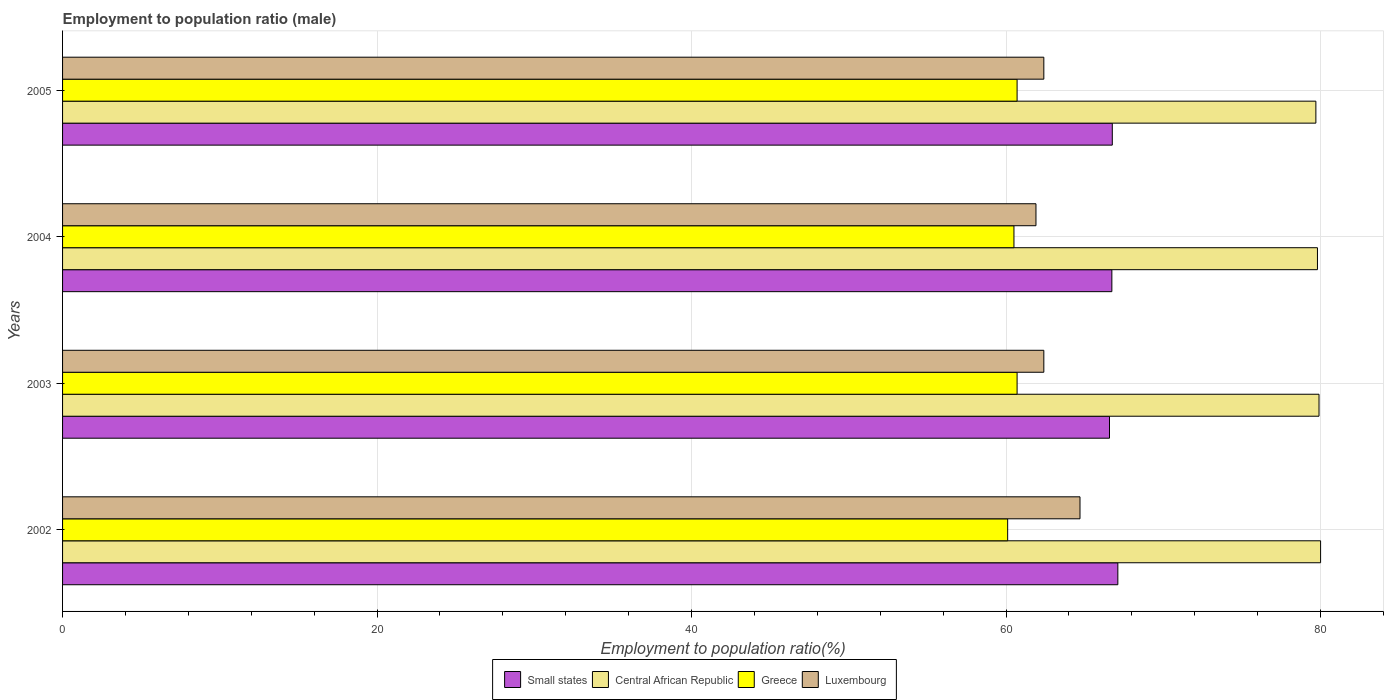How many different coloured bars are there?
Your response must be concise. 4. Are the number of bars on each tick of the Y-axis equal?
Offer a very short reply. Yes. What is the label of the 3rd group of bars from the top?
Make the answer very short. 2003. In how many cases, is the number of bars for a given year not equal to the number of legend labels?
Your answer should be compact. 0. What is the employment to population ratio in Greece in 2005?
Offer a very short reply. 60.7. Across all years, what is the maximum employment to population ratio in Luxembourg?
Give a very brief answer. 64.7. Across all years, what is the minimum employment to population ratio in Luxembourg?
Your answer should be compact. 61.9. In which year was the employment to population ratio in Small states maximum?
Ensure brevity in your answer.  2002. In which year was the employment to population ratio in Greece minimum?
Keep it short and to the point. 2002. What is the total employment to population ratio in Central African Republic in the graph?
Your answer should be compact. 319.4. What is the difference between the employment to population ratio in Small states in 2004 and that in 2005?
Your answer should be very brief. -0.03. What is the difference between the employment to population ratio in Central African Republic in 2004 and the employment to population ratio in Greece in 2002?
Keep it short and to the point. 19.7. What is the average employment to population ratio in Luxembourg per year?
Give a very brief answer. 62.85. In the year 2004, what is the difference between the employment to population ratio in Central African Republic and employment to population ratio in Small states?
Your answer should be very brief. 13.07. What is the ratio of the employment to population ratio in Greece in 2003 to that in 2004?
Keep it short and to the point. 1. What is the difference between the highest and the second highest employment to population ratio in Central African Republic?
Provide a short and direct response. 0.1. What is the difference between the highest and the lowest employment to population ratio in Central African Republic?
Provide a short and direct response. 0.3. Is the sum of the employment to population ratio in Small states in 2003 and 2005 greater than the maximum employment to population ratio in Central African Republic across all years?
Keep it short and to the point. Yes. Is it the case that in every year, the sum of the employment to population ratio in Greece and employment to population ratio in Small states is greater than the sum of employment to population ratio in Luxembourg and employment to population ratio in Central African Republic?
Offer a very short reply. No. What does the 1st bar from the top in 2002 represents?
Keep it short and to the point. Luxembourg. What does the 2nd bar from the bottom in 2002 represents?
Give a very brief answer. Central African Republic. Are all the bars in the graph horizontal?
Make the answer very short. Yes. Where does the legend appear in the graph?
Give a very brief answer. Bottom center. How many legend labels are there?
Provide a short and direct response. 4. What is the title of the graph?
Your answer should be very brief. Employment to population ratio (male). Does "Australia" appear as one of the legend labels in the graph?
Your answer should be compact. No. What is the label or title of the X-axis?
Make the answer very short. Employment to population ratio(%). What is the Employment to population ratio(%) of Small states in 2002?
Provide a succinct answer. 67.11. What is the Employment to population ratio(%) of Central African Republic in 2002?
Ensure brevity in your answer.  80. What is the Employment to population ratio(%) in Greece in 2002?
Keep it short and to the point. 60.1. What is the Employment to population ratio(%) in Luxembourg in 2002?
Ensure brevity in your answer.  64.7. What is the Employment to population ratio(%) of Small states in 2003?
Provide a short and direct response. 66.58. What is the Employment to population ratio(%) in Central African Republic in 2003?
Provide a succinct answer. 79.9. What is the Employment to population ratio(%) in Greece in 2003?
Offer a very short reply. 60.7. What is the Employment to population ratio(%) of Luxembourg in 2003?
Ensure brevity in your answer.  62.4. What is the Employment to population ratio(%) in Small states in 2004?
Your answer should be compact. 66.73. What is the Employment to population ratio(%) in Central African Republic in 2004?
Ensure brevity in your answer.  79.8. What is the Employment to population ratio(%) of Greece in 2004?
Your response must be concise. 60.5. What is the Employment to population ratio(%) of Luxembourg in 2004?
Offer a very short reply. 61.9. What is the Employment to population ratio(%) of Small states in 2005?
Offer a very short reply. 66.75. What is the Employment to population ratio(%) of Central African Republic in 2005?
Offer a very short reply. 79.7. What is the Employment to population ratio(%) of Greece in 2005?
Offer a very short reply. 60.7. What is the Employment to population ratio(%) in Luxembourg in 2005?
Make the answer very short. 62.4. Across all years, what is the maximum Employment to population ratio(%) in Small states?
Ensure brevity in your answer.  67.11. Across all years, what is the maximum Employment to population ratio(%) in Central African Republic?
Offer a terse response. 80. Across all years, what is the maximum Employment to population ratio(%) in Greece?
Keep it short and to the point. 60.7. Across all years, what is the maximum Employment to population ratio(%) in Luxembourg?
Keep it short and to the point. 64.7. Across all years, what is the minimum Employment to population ratio(%) of Small states?
Give a very brief answer. 66.58. Across all years, what is the minimum Employment to population ratio(%) of Central African Republic?
Give a very brief answer. 79.7. Across all years, what is the minimum Employment to population ratio(%) in Greece?
Your answer should be very brief. 60.1. Across all years, what is the minimum Employment to population ratio(%) in Luxembourg?
Provide a short and direct response. 61.9. What is the total Employment to population ratio(%) of Small states in the graph?
Give a very brief answer. 267.16. What is the total Employment to population ratio(%) of Central African Republic in the graph?
Your response must be concise. 319.4. What is the total Employment to population ratio(%) in Greece in the graph?
Your answer should be compact. 242. What is the total Employment to population ratio(%) of Luxembourg in the graph?
Your answer should be compact. 251.4. What is the difference between the Employment to population ratio(%) in Small states in 2002 and that in 2003?
Your response must be concise. 0.53. What is the difference between the Employment to population ratio(%) in Luxembourg in 2002 and that in 2003?
Offer a very short reply. 2.3. What is the difference between the Employment to population ratio(%) in Small states in 2002 and that in 2004?
Keep it short and to the point. 0.38. What is the difference between the Employment to population ratio(%) in Greece in 2002 and that in 2004?
Keep it short and to the point. -0.4. What is the difference between the Employment to population ratio(%) of Small states in 2002 and that in 2005?
Your answer should be compact. 0.35. What is the difference between the Employment to population ratio(%) in Central African Republic in 2002 and that in 2005?
Keep it short and to the point. 0.3. What is the difference between the Employment to population ratio(%) in Greece in 2002 and that in 2005?
Your answer should be very brief. -0.6. What is the difference between the Employment to population ratio(%) of Small states in 2003 and that in 2004?
Your answer should be compact. -0.15. What is the difference between the Employment to population ratio(%) in Central African Republic in 2003 and that in 2004?
Keep it short and to the point. 0.1. What is the difference between the Employment to population ratio(%) of Small states in 2003 and that in 2005?
Provide a succinct answer. -0.18. What is the difference between the Employment to population ratio(%) in Central African Republic in 2003 and that in 2005?
Your answer should be very brief. 0.2. What is the difference between the Employment to population ratio(%) in Luxembourg in 2003 and that in 2005?
Make the answer very short. 0. What is the difference between the Employment to population ratio(%) of Small states in 2004 and that in 2005?
Offer a terse response. -0.03. What is the difference between the Employment to population ratio(%) in Small states in 2002 and the Employment to population ratio(%) in Central African Republic in 2003?
Make the answer very short. -12.79. What is the difference between the Employment to population ratio(%) in Small states in 2002 and the Employment to population ratio(%) in Greece in 2003?
Your answer should be compact. 6.41. What is the difference between the Employment to population ratio(%) of Small states in 2002 and the Employment to population ratio(%) of Luxembourg in 2003?
Your response must be concise. 4.71. What is the difference between the Employment to population ratio(%) in Central African Republic in 2002 and the Employment to population ratio(%) in Greece in 2003?
Offer a terse response. 19.3. What is the difference between the Employment to population ratio(%) of Central African Republic in 2002 and the Employment to population ratio(%) of Luxembourg in 2003?
Your response must be concise. 17.6. What is the difference between the Employment to population ratio(%) in Small states in 2002 and the Employment to population ratio(%) in Central African Republic in 2004?
Make the answer very short. -12.69. What is the difference between the Employment to population ratio(%) of Small states in 2002 and the Employment to population ratio(%) of Greece in 2004?
Offer a terse response. 6.61. What is the difference between the Employment to population ratio(%) in Small states in 2002 and the Employment to population ratio(%) in Luxembourg in 2004?
Make the answer very short. 5.21. What is the difference between the Employment to population ratio(%) of Central African Republic in 2002 and the Employment to population ratio(%) of Greece in 2004?
Make the answer very short. 19.5. What is the difference between the Employment to population ratio(%) of Small states in 2002 and the Employment to population ratio(%) of Central African Republic in 2005?
Offer a terse response. -12.59. What is the difference between the Employment to population ratio(%) in Small states in 2002 and the Employment to population ratio(%) in Greece in 2005?
Provide a short and direct response. 6.41. What is the difference between the Employment to population ratio(%) in Small states in 2002 and the Employment to population ratio(%) in Luxembourg in 2005?
Make the answer very short. 4.71. What is the difference between the Employment to population ratio(%) in Central African Republic in 2002 and the Employment to population ratio(%) in Greece in 2005?
Make the answer very short. 19.3. What is the difference between the Employment to population ratio(%) in Small states in 2003 and the Employment to population ratio(%) in Central African Republic in 2004?
Make the answer very short. -13.22. What is the difference between the Employment to population ratio(%) in Small states in 2003 and the Employment to population ratio(%) in Greece in 2004?
Ensure brevity in your answer.  6.08. What is the difference between the Employment to population ratio(%) of Small states in 2003 and the Employment to population ratio(%) of Luxembourg in 2004?
Keep it short and to the point. 4.68. What is the difference between the Employment to population ratio(%) of Central African Republic in 2003 and the Employment to population ratio(%) of Greece in 2004?
Keep it short and to the point. 19.4. What is the difference between the Employment to population ratio(%) of Small states in 2003 and the Employment to population ratio(%) of Central African Republic in 2005?
Give a very brief answer. -13.12. What is the difference between the Employment to population ratio(%) of Small states in 2003 and the Employment to population ratio(%) of Greece in 2005?
Make the answer very short. 5.88. What is the difference between the Employment to population ratio(%) in Small states in 2003 and the Employment to population ratio(%) in Luxembourg in 2005?
Provide a short and direct response. 4.18. What is the difference between the Employment to population ratio(%) of Central African Republic in 2003 and the Employment to population ratio(%) of Greece in 2005?
Keep it short and to the point. 19.2. What is the difference between the Employment to population ratio(%) of Greece in 2003 and the Employment to population ratio(%) of Luxembourg in 2005?
Give a very brief answer. -1.7. What is the difference between the Employment to population ratio(%) in Small states in 2004 and the Employment to population ratio(%) in Central African Republic in 2005?
Keep it short and to the point. -12.97. What is the difference between the Employment to population ratio(%) of Small states in 2004 and the Employment to population ratio(%) of Greece in 2005?
Provide a short and direct response. 6.03. What is the difference between the Employment to population ratio(%) of Small states in 2004 and the Employment to population ratio(%) of Luxembourg in 2005?
Offer a terse response. 4.33. What is the difference between the Employment to population ratio(%) of Central African Republic in 2004 and the Employment to population ratio(%) of Greece in 2005?
Your response must be concise. 19.1. What is the difference between the Employment to population ratio(%) of Central African Republic in 2004 and the Employment to population ratio(%) of Luxembourg in 2005?
Offer a terse response. 17.4. What is the difference between the Employment to population ratio(%) of Greece in 2004 and the Employment to population ratio(%) of Luxembourg in 2005?
Your answer should be very brief. -1.9. What is the average Employment to population ratio(%) in Small states per year?
Provide a short and direct response. 66.79. What is the average Employment to population ratio(%) of Central African Republic per year?
Make the answer very short. 79.85. What is the average Employment to population ratio(%) in Greece per year?
Provide a succinct answer. 60.5. What is the average Employment to population ratio(%) of Luxembourg per year?
Offer a terse response. 62.85. In the year 2002, what is the difference between the Employment to population ratio(%) of Small states and Employment to population ratio(%) of Central African Republic?
Give a very brief answer. -12.89. In the year 2002, what is the difference between the Employment to population ratio(%) in Small states and Employment to population ratio(%) in Greece?
Keep it short and to the point. 7.01. In the year 2002, what is the difference between the Employment to population ratio(%) in Small states and Employment to population ratio(%) in Luxembourg?
Give a very brief answer. 2.41. In the year 2002, what is the difference between the Employment to population ratio(%) of Central African Republic and Employment to population ratio(%) of Greece?
Your answer should be very brief. 19.9. In the year 2002, what is the difference between the Employment to population ratio(%) in Central African Republic and Employment to population ratio(%) in Luxembourg?
Your answer should be very brief. 15.3. In the year 2002, what is the difference between the Employment to population ratio(%) of Greece and Employment to population ratio(%) of Luxembourg?
Your answer should be very brief. -4.6. In the year 2003, what is the difference between the Employment to population ratio(%) of Small states and Employment to population ratio(%) of Central African Republic?
Offer a terse response. -13.32. In the year 2003, what is the difference between the Employment to population ratio(%) of Small states and Employment to population ratio(%) of Greece?
Offer a very short reply. 5.88. In the year 2003, what is the difference between the Employment to population ratio(%) of Small states and Employment to population ratio(%) of Luxembourg?
Your response must be concise. 4.18. In the year 2003, what is the difference between the Employment to population ratio(%) in Central African Republic and Employment to population ratio(%) in Greece?
Offer a terse response. 19.2. In the year 2003, what is the difference between the Employment to population ratio(%) in Central African Republic and Employment to population ratio(%) in Luxembourg?
Give a very brief answer. 17.5. In the year 2004, what is the difference between the Employment to population ratio(%) in Small states and Employment to population ratio(%) in Central African Republic?
Ensure brevity in your answer.  -13.07. In the year 2004, what is the difference between the Employment to population ratio(%) in Small states and Employment to population ratio(%) in Greece?
Your answer should be compact. 6.23. In the year 2004, what is the difference between the Employment to population ratio(%) of Small states and Employment to population ratio(%) of Luxembourg?
Your response must be concise. 4.83. In the year 2004, what is the difference between the Employment to population ratio(%) of Central African Republic and Employment to population ratio(%) of Greece?
Give a very brief answer. 19.3. In the year 2004, what is the difference between the Employment to population ratio(%) of Central African Republic and Employment to population ratio(%) of Luxembourg?
Your answer should be compact. 17.9. In the year 2004, what is the difference between the Employment to population ratio(%) of Greece and Employment to population ratio(%) of Luxembourg?
Your answer should be very brief. -1.4. In the year 2005, what is the difference between the Employment to population ratio(%) in Small states and Employment to population ratio(%) in Central African Republic?
Offer a very short reply. -12.95. In the year 2005, what is the difference between the Employment to population ratio(%) of Small states and Employment to population ratio(%) of Greece?
Your response must be concise. 6.05. In the year 2005, what is the difference between the Employment to population ratio(%) of Small states and Employment to population ratio(%) of Luxembourg?
Ensure brevity in your answer.  4.35. In the year 2005, what is the difference between the Employment to population ratio(%) of Central African Republic and Employment to population ratio(%) of Greece?
Make the answer very short. 19. In the year 2005, what is the difference between the Employment to population ratio(%) of Greece and Employment to population ratio(%) of Luxembourg?
Give a very brief answer. -1.7. What is the ratio of the Employment to population ratio(%) in Luxembourg in 2002 to that in 2003?
Provide a short and direct response. 1.04. What is the ratio of the Employment to population ratio(%) in Small states in 2002 to that in 2004?
Your answer should be compact. 1.01. What is the ratio of the Employment to population ratio(%) of Central African Republic in 2002 to that in 2004?
Ensure brevity in your answer.  1. What is the ratio of the Employment to population ratio(%) of Greece in 2002 to that in 2004?
Make the answer very short. 0.99. What is the ratio of the Employment to population ratio(%) of Luxembourg in 2002 to that in 2004?
Provide a short and direct response. 1.05. What is the ratio of the Employment to population ratio(%) in Central African Republic in 2002 to that in 2005?
Your answer should be very brief. 1. What is the ratio of the Employment to population ratio(%) of Greece in 2002 to that in 2005?
Keep it short and to the point. 0.99. What is the ratio of the Employment to population ratio(%) of Luxembourg in 2002 to that in 2005?
Your answer should be compact. 1.04. What is the ratio of the Employment to population ratio(%) of Small states in 2003 to that in 2004?
Provide a short and direct response. 1. What is the ratio of the Employment to population ratio(%) in Central African Republic in 2003 to that in 2004?
Give a very brief answer. 1. What is the ratio of the Employment to population ratio(%) in Greece in 2003 to that in 2004?
Keep it short and to the point. 1. What is the ratio of the Employment to population ratio(%) in Luxembourg in 2003 to that in 2004?
Provide a short and direct response. 1.01. What is the ratio of the Employment to population ratio(%) in Central African Republic in 2003 to that in 2005?
Make the answer very short. 1. What is the ratio of the Employment to population ratio(%) in Luxembourg in 2003 to that in 2005?
Give a very brief answer. 1. What is the ratio of the Employment to population ratio(%) of Small states in 2004 to that in 2005?
Ensure brevity in your answer.  1. What is the ratio of the Employment to population ratio(%) of Central African Republic in 2004 to that in 2005?
Your answer should be compact. 1. What is the ratio of the Employment to population ratio(%) of Luxembourg in 2004 to that in 2005?
Provide a short and direct response. 0.99. What is the difference between the highest and the second highest Employment to population ratio(%) of Small states?
Your response must be concise. 0.35. What is the difference between the highest and the second highest Employment to population ratio(%) in Central African Republic?
Ensure brevity in your answer.  0.1. What is the difference between the highest and the second highest Employment to population ratio(%) in Greece?
Your response must be concise. 0. What is the difference between the highest and the lowest Employment to population ratio(%) of Small states?
Ensure brevity in your answer.  0.53. What is the difference between the highest and the lowest Employment to population ratio(%) of Central African Republic?
Offer a very short reply. 0.3. What is the difference between the highest and the lowest Employment to population ratio(%) of Luxembourg?
Ensure brevity in your answer.  2.8. 